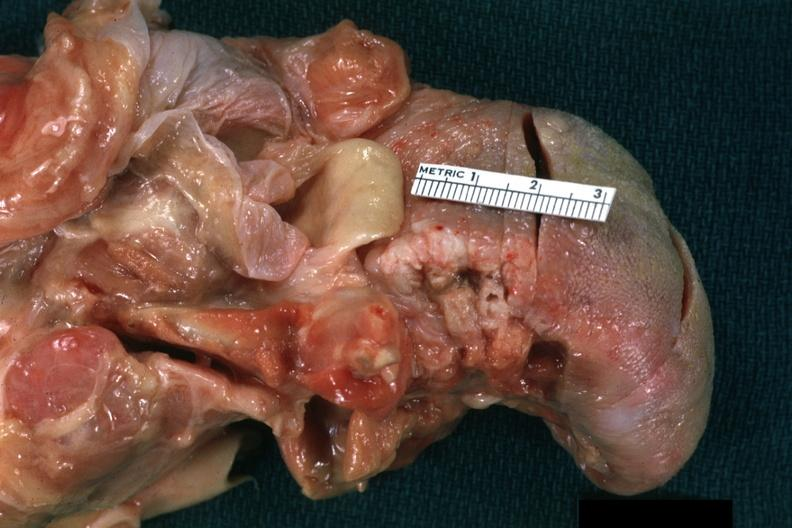what does this image show?
Answer the question using a single word or phrase. View of ulcerative lesion at base of tongue laterally quite good 